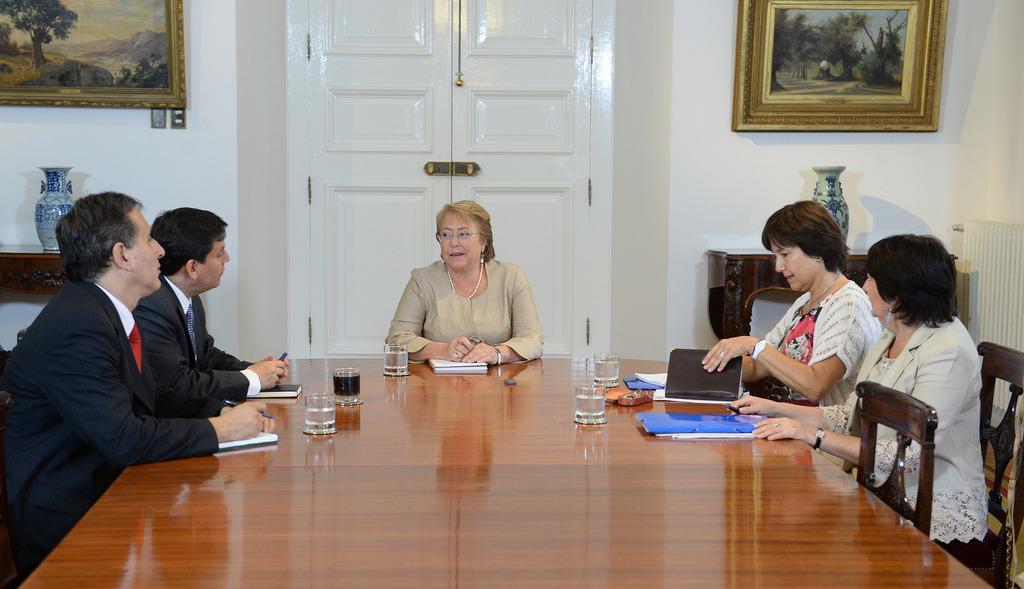How would you summarize this image in a sentence or two? In this image I can see group of people siting in front of the table. On the table there are books and the glasses. In the back ground there are flower vases and the frames attached to the wall. 